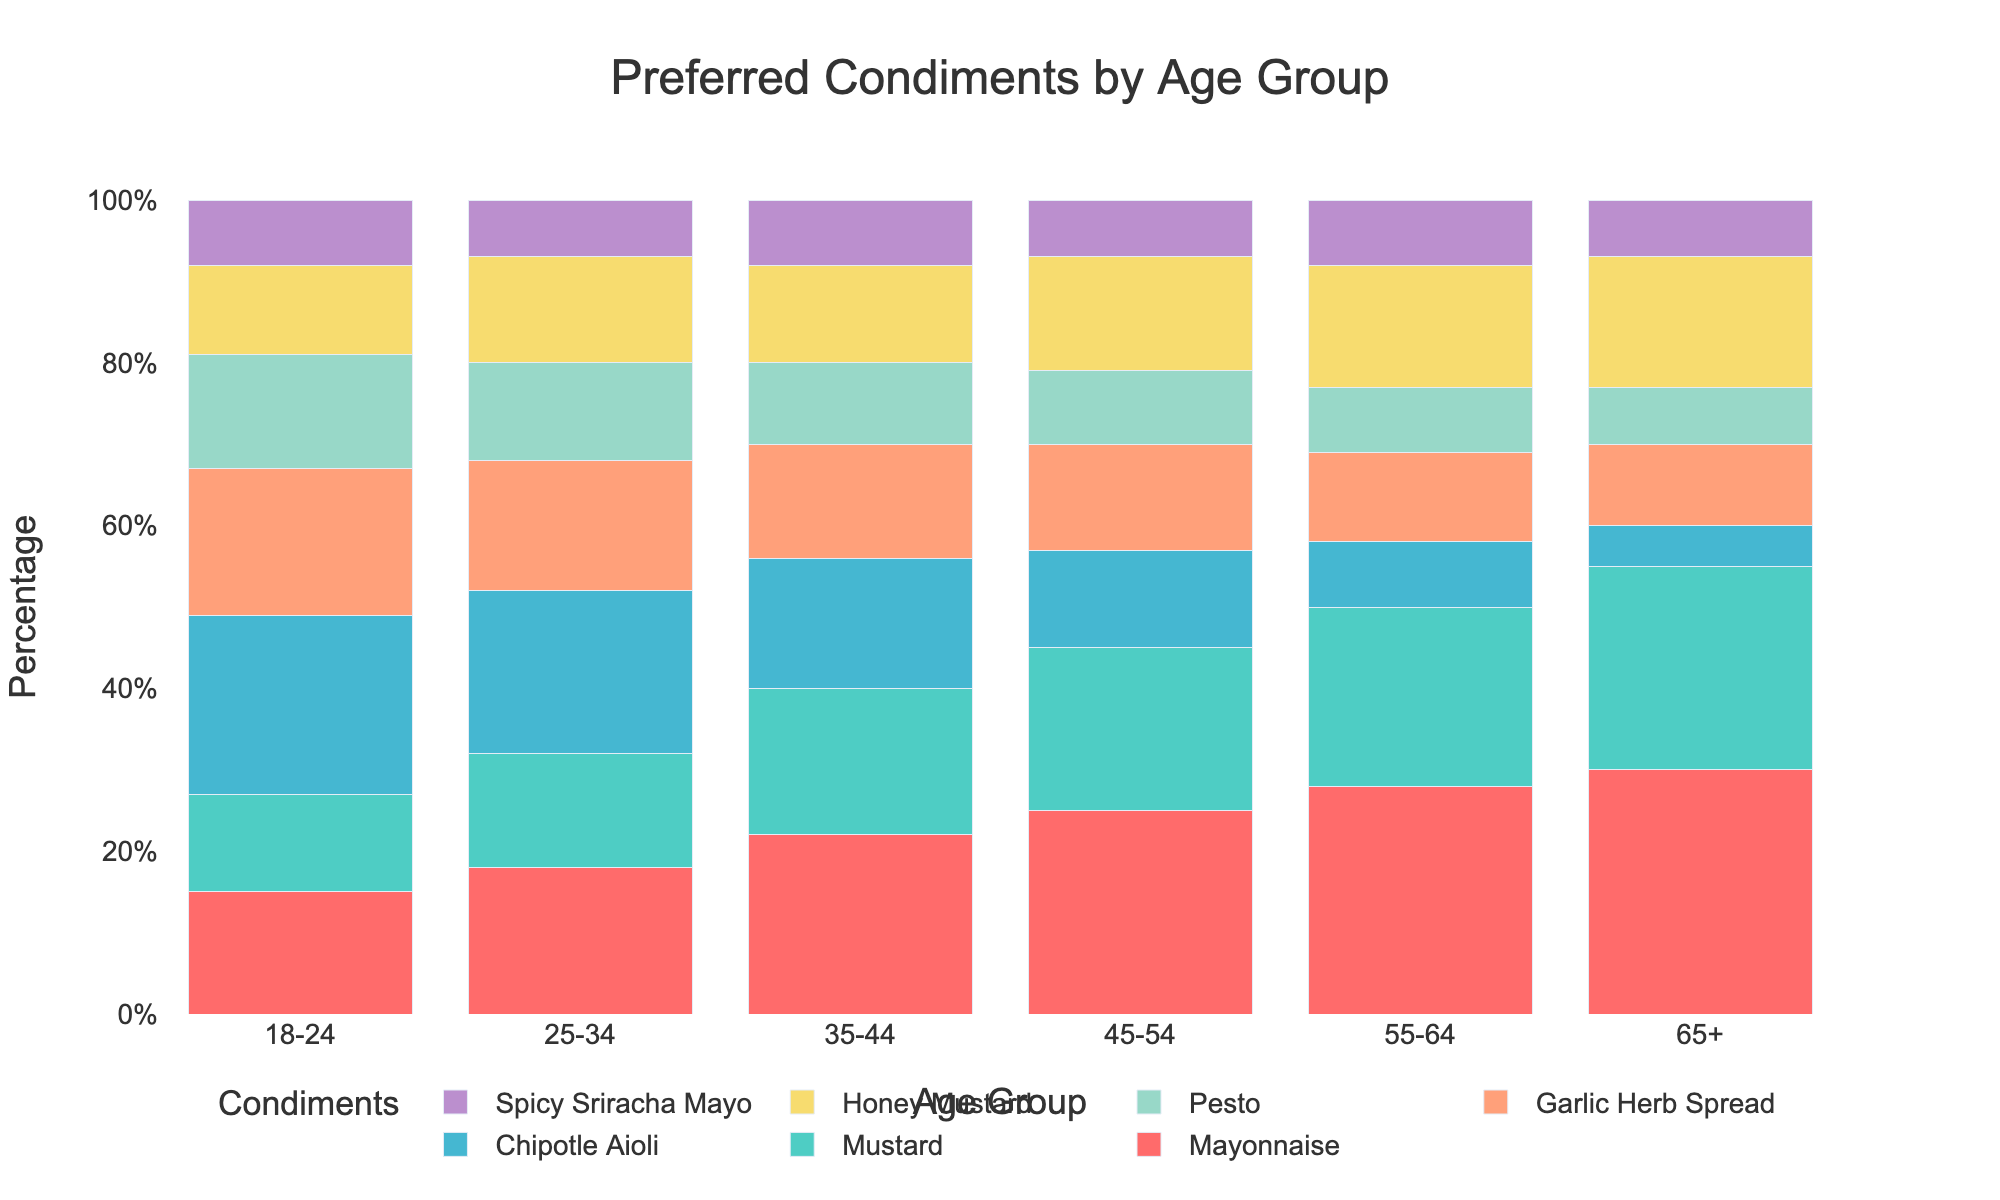Which age group prefers Mayonnaise the most? Look at the bar heights for Mayonnaise across all age groups. The highest bar corresponds to the 65+ age group.
Answer: 65+ What is the combined percentage of Garlic Herb Spread preference for age groups 18-24 and 25-34? Add the percentages for Garlic Herb Spread for the age groups 18-24 (18%) and 25-34 (16%). 18% + 16% = 34%
Answer: 34% Which condiment has the most consistent preference (least variation) across age groups? Review the visual heights of the bars for all condiments. Condiments with minimal fluctuation in bar height across age groups have the least variation. Spicy Sriracha Mayo shows the most consistent bar heights, generally around the same percentage across all age groups.
Answer: Spicy Sriracha Mayo In which age group is Pesto the least preferred? Identify the shortest Pesto bar among all age groups. The shortest bar for Pesto is in the 65+ age group.
Answer: 65+ How does the preference for Honey Mustard change from the 18-24 age group to the 55-64 age group? Subtract the percentage of Honey Mustard preference in the 18-24 age group (11%) from the percentage in the 55-64 age group (15%). 15% - 11% = 4% increase.
Answer: 4% increase Which condiment shows the largest increase in preference from the 18-24 age group to the 65+ age group? Calculate the increase in percentage for each condiment from the 18-24 to the 65+ age group. Identify the condiment with the largest increase, which is Mayonnaise, increasing from 15% to 30% (30% - 15% = 15%).
Answer: Mayonnaise What is the average preference for Mustard across all age groups? Add the Mustard percentages for all age groups and then divide by the number of age groups: (12% + 14% + 18% + 20% + 22% + 25%) / 6. (111%) / 6 = 18.5%.
Answer: 18.5% Which condiment has the highest preference among the 45-54 age group? Identify the tallest bar in the 45-54 age group. The tallest bar corresponds to Mayonnaise with 25%.
Answer: Mayonnaise 